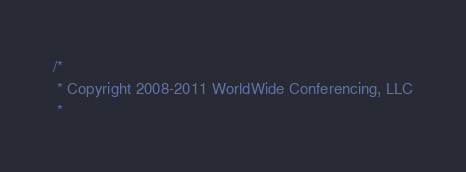<code> <loc_0><loc_0><loc_500><loc_500><_Scala_>/*
 * Copyright 2008-2011 WorldWide Conferencing, LLC
 *</code> 